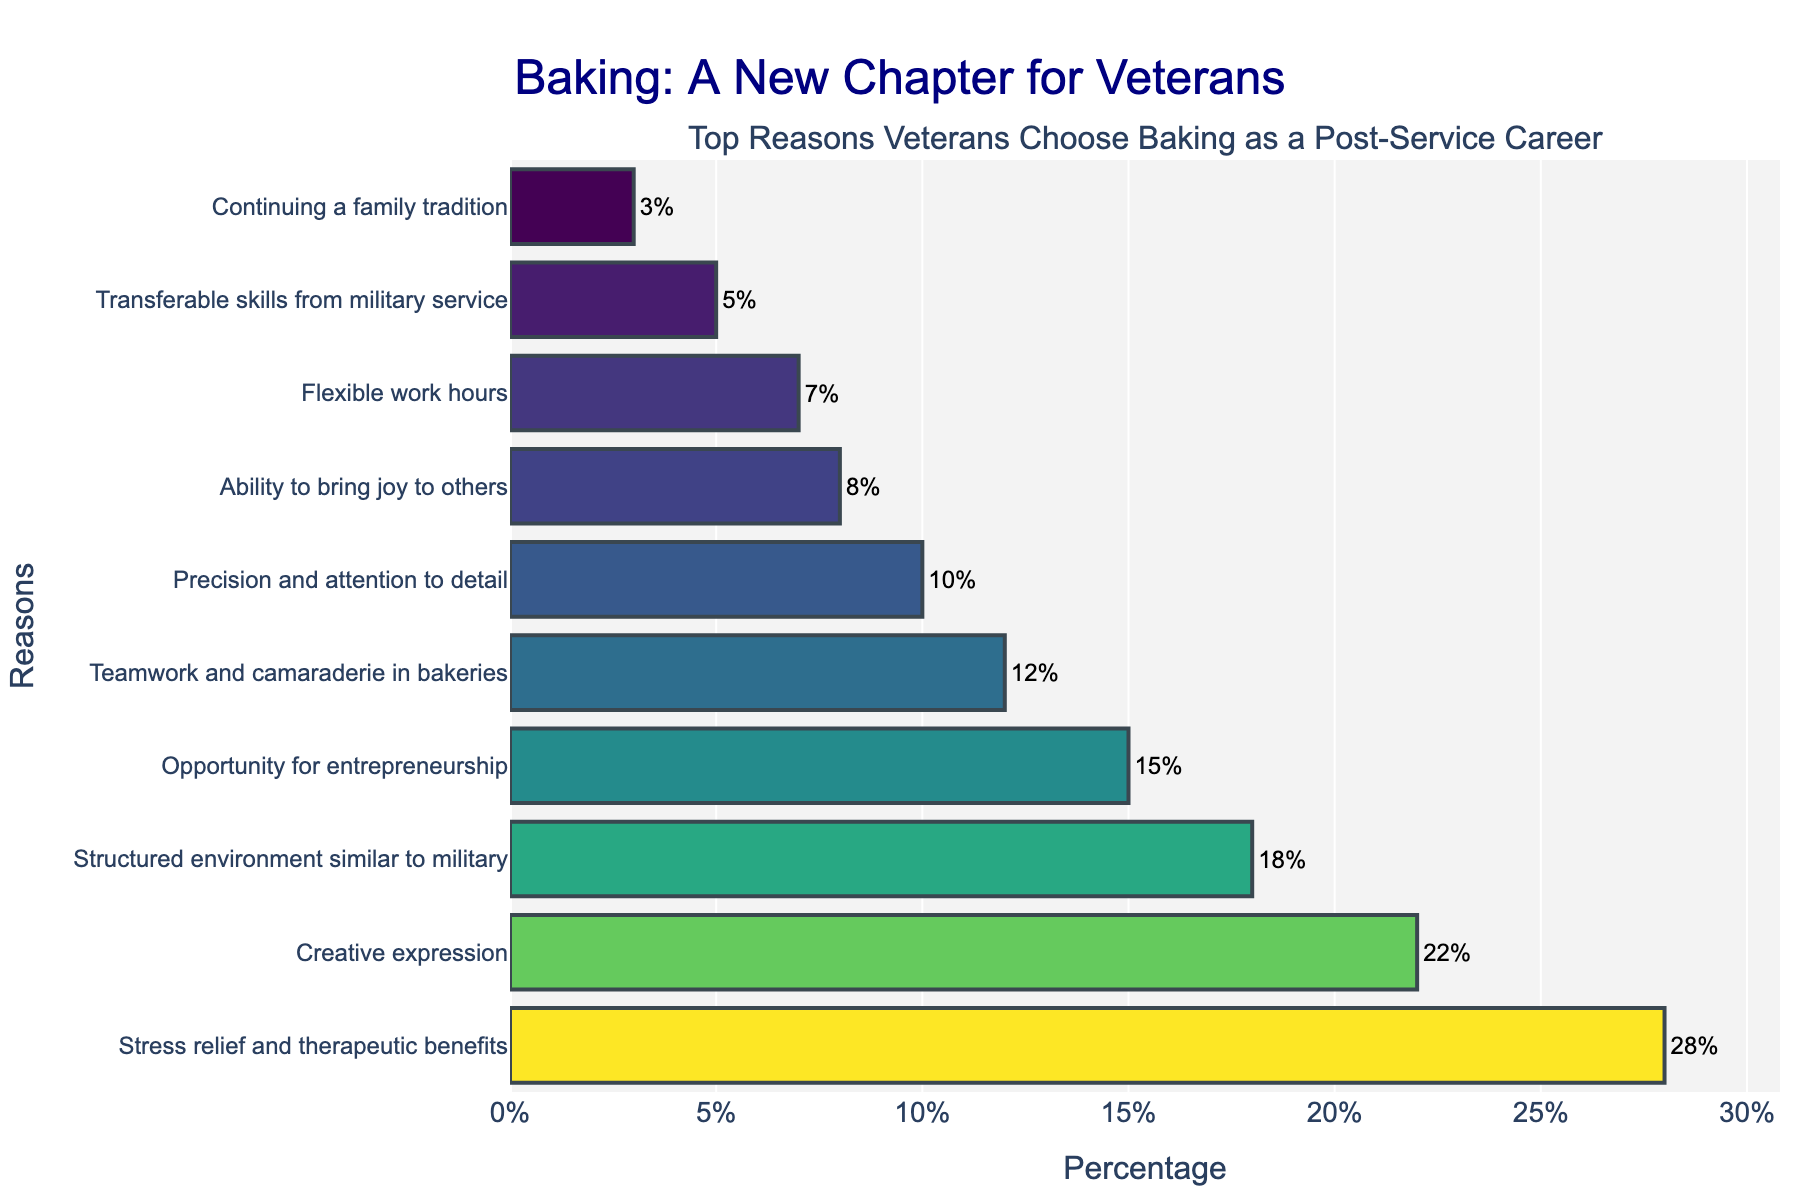What's the most common reason veterans choose baking as a post-service career? The highest bar in the figure represents "Stress relief and therapeutic benefits" with a percentage of 28%. This indicates it's the most common reason.
Answer: Stress relief and therapeutic benefits Which reason has a higher percentage: "Creative expression" or "Flexibility in work hours"? The bar for "Creative expression" is taller and is at 22%, while the bar for "Flexible work hours" is shorter and is at 7%. Therefore, "Creative expression" has a higher percentage.
Answer: Creative expression What is the total percentage for the top three reasons veterans choose baking? The top three reasons are "Stress relief and therapeutic benefits" (28%), "Creative expression" (22%), and "Structured environment similar to military" (18%). The sum is 28 + 22 + 18 = 68%.
Answer: 68% Is the percentage for "Ability to bring joy to others" higher or lower compared to "Teamwork and camaraderie in bakeries"? The bar representing "Ability to bring joy to others" shows 8%, whereas "Teamwork and camaraderie in bakeries" is shown at 12%. Therefore, "Ability to bring joy to others" has a lower percentage.
Answer: Lower How does the percentage of "Transferable skills from military service" compare to "Continuing a family tradition"? The percentage for "Transferable skills from military service" is 5%, while for "Continuing a family tradition" it is 3%. Thus, "Transferable skills from military service" is higher.
Answer: Higher Which color on the bar chart indicates the highest percentage reason? The bar indicating the highest percentage reason ("Stress relief and therapeutic benefits" at 28%) is represented by the darkest shade on the Viridis colorscale, typically dark green or blue.
Answer: Dark green/blue What is the difference in percentage between the reasons "Opportunity for entrepreneurship" and "Precision and attention to detail"? "Opportunity for entrepreneurship" has a percentage of 15%, while "Precision and attention to detail" shows 10%. The difference is 15 - 10 = 5%.
Answer: 5% What is the combined percentage for the reasons "Teamwork and camaraderie in bakeries," "Precision and attention to detail," and "Ability to bring joy to others"? The percentages are 12% for "Teamwork and camaraderie in bakeries," 10% for "Precision and attention to detail," and 8% for "Ability to bring joy to others." Adding these gives 12 + 10 + 8 = 30%.
Answer: 30% Which reasons have a percentage below 10%? The reasons below 10% are "Ability to bring joy to others" (8%), "Flexible work hours" (7%), "Transferable skills from military service" (5%), and "Continuing a family tradition" (3%).
Answer: Ability to bring joy to others, Flexible work hours, Transferable skills from military service, Continuing a family tradition 